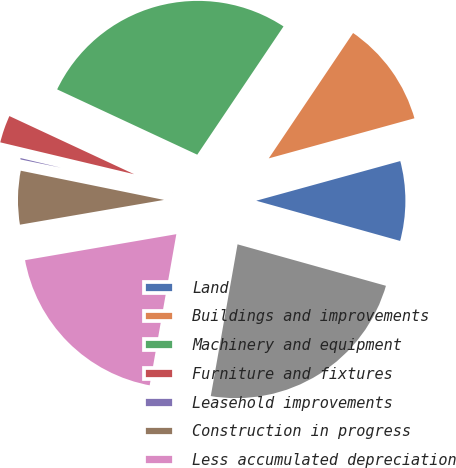<chart> <loc_0><loc_0><loc_500><loc_500><pie_chart><fcel>Land<fcel>Buildings and improvements<fcel>Machinery and equipment<fcel>Furniture and fixtures<fcel>Leasehold improvements<fcel>Construction in progress<fcel>Less accumulated depreciation<fcel>Net property plant and<nl><fcel>8.61%<fcel>11.3%<fcel>27.48%<fcel>3.22%<fcel>0.52%<fcel>5.91%<fcel>19.51%<fcel>23.44%<nl></chart> 